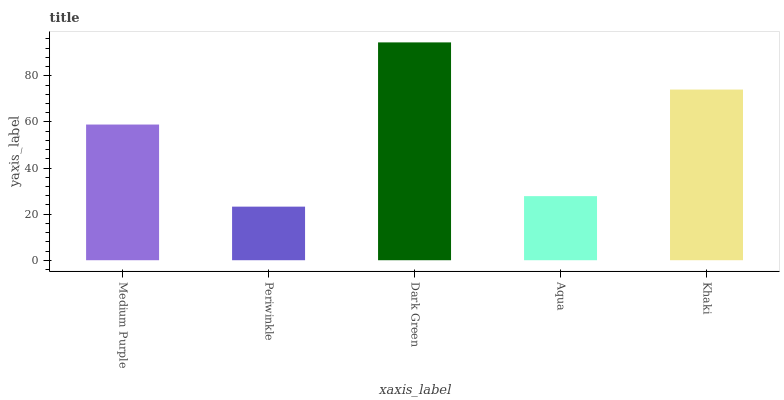Is Periwinkle the minimum?
Answer yes or no. Yes. Is Dark Green the maximum?
Answer yes or no. Yes. Is Dark Green the minimum?
Answer yes or no. No. Is Periwinkle the maximum?
Answer yes or no. No. Is Dark Green greater than Periwinkle?
Answer yes or no. Yes. Is Periwinkle less than Dark Green?
Answer yes or no. Yes. Is Periwinkle greater than Dark Green?
Answer yes or no. No. Is Dark Green less than Periwinkle?
Answer yes or no. No. Is Medium Purple the high median?
Answer yes or no. Yes. Is Medium Purple the low median?
Answer yes or no. Yes. Is Periwinkle the high median?
Answer yes or no. No. Is Aqua the low median?
Answer yes or no. No. 